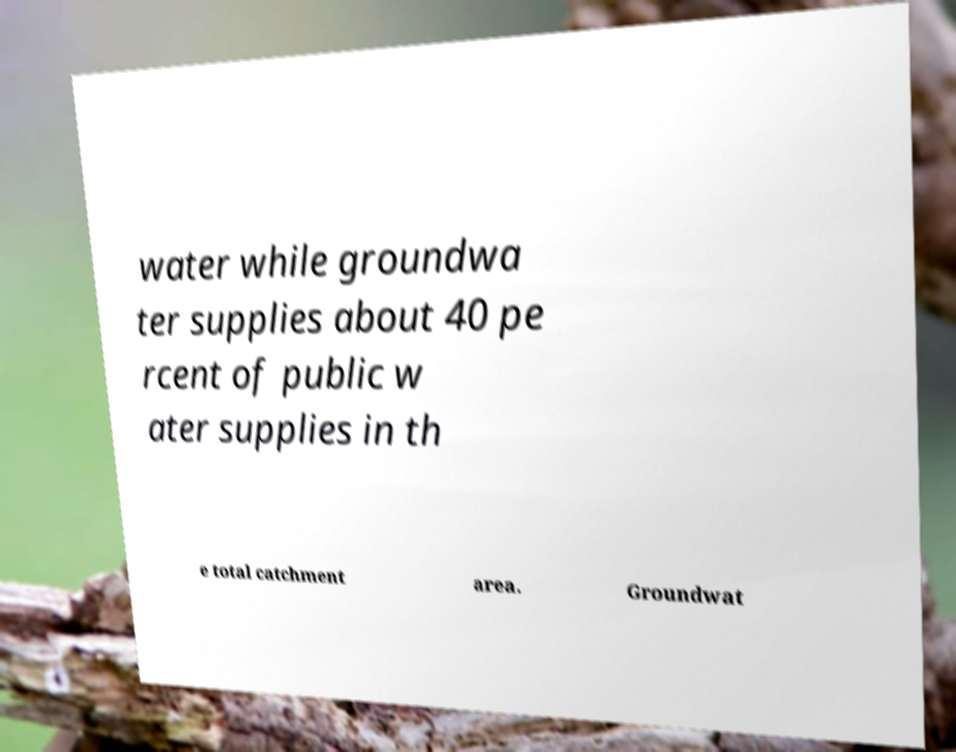I need the written content from this picture converted into text. Can you do that? water while groundwa ter supplies about 40 pe rcent of public w ater supplies in th e total catchment area. Groundwat 